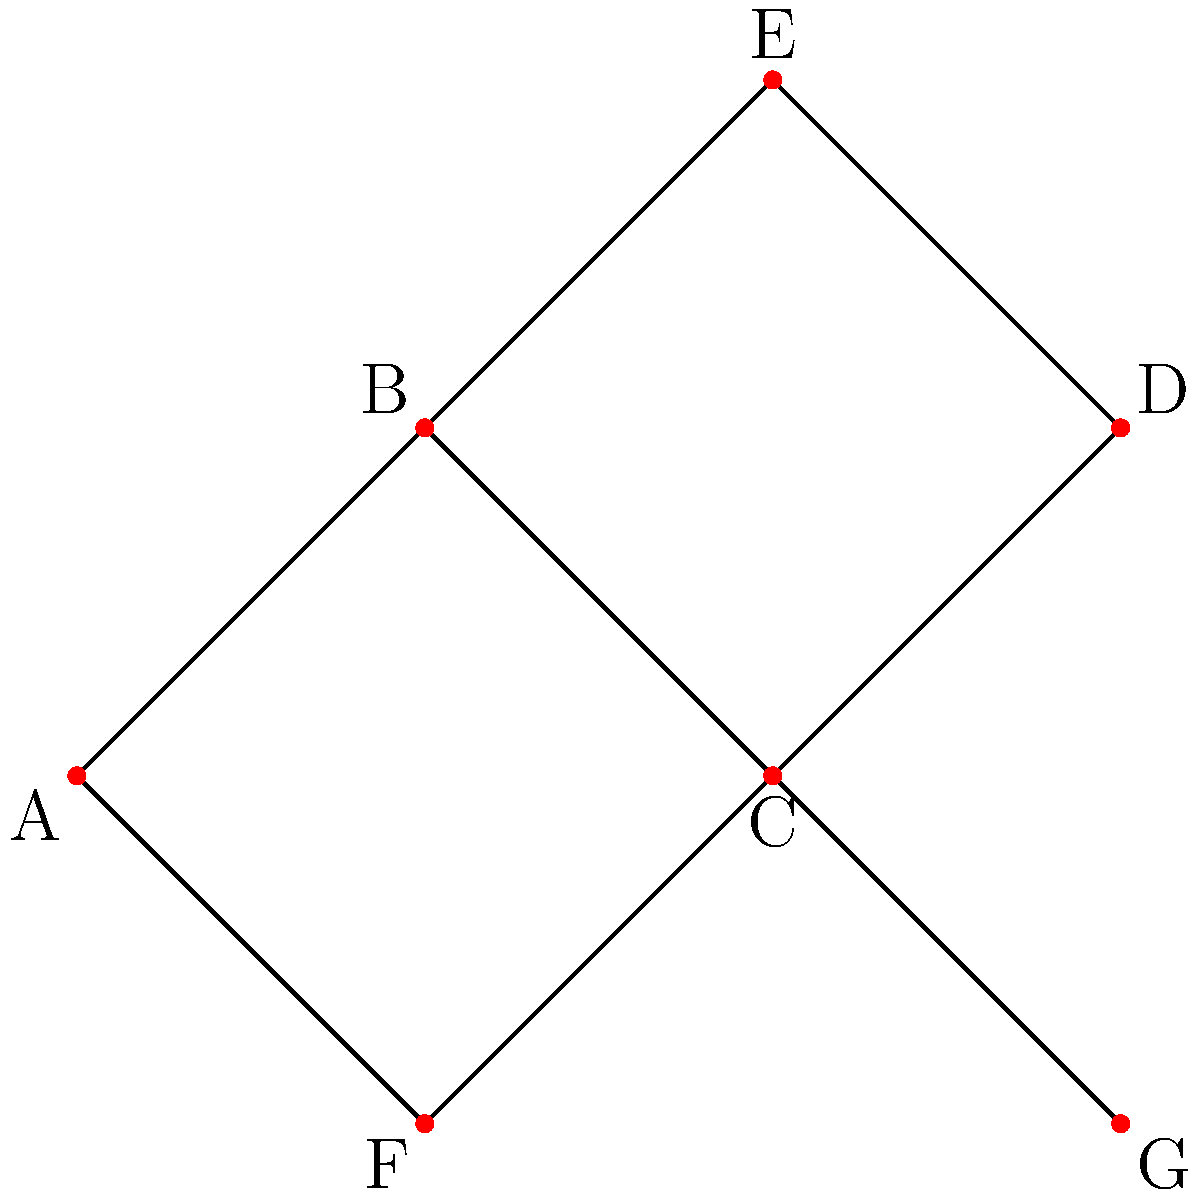As a PR specialist, you're analyzing the potential reach of a viral post using a network diagram. In this diagram, each node represents a person, and each edge represents a connection through which the post can be shared. If the post starts at node A and each person has a 50% chance of sharing it with their direct connections, what is the expected number of people who will see the post (including A)? Let's approach this step-by-step:

1) First, we need to count the number of connections for each node:
   A: 2 connections (B, F)
   B: 3 connections (A, C, E)
   C: 4 connections (B, D, F, G)
   D: 2 connections (C, E)
   E: 2 connections (B, D)
   F: 2 connections (A, C)
   G: 1 connection (C)

2) Now, let's calculate the probability of the post reaching each node:
   A: 100% (starting point)
   B: 50% (directly from A)
   C: 75% (50% from A through B, plus 50% of the remaining 50% from A through F)
   D: 37.5% (75% * 50% from C)
   E: 25% (50% * 50% from B)
   F: 50% (directly from A)
   G: 37.5% (75% * 50% from C)

3) To calculate the expected number of people who will see the post, we sum these probabilities:

   $$ 1 + 0.5 + 0.75 + 0.375 + 0.25 + 0.5 + 0.375 = 3.75 $$

Therefore, the expected number of people who will see the post is 3.75.
Answer: 3.75 people 